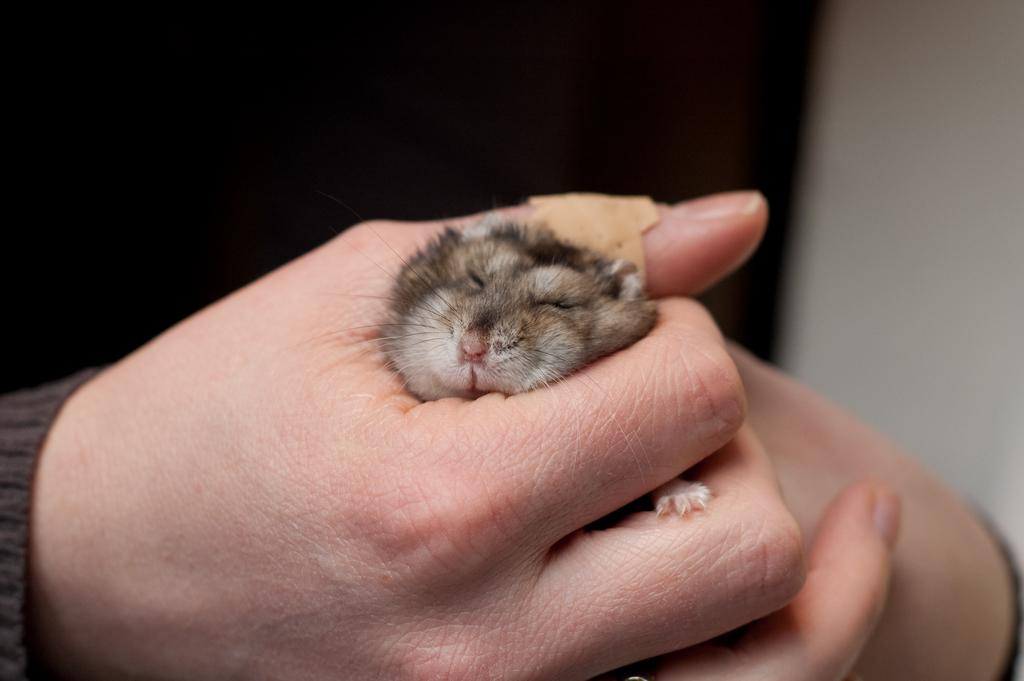What is being held by the hands in the image? The hands of a person are holding a rat in the image. Can you describe the background of the image? The background of the image is blurred. What is the purpose of the man standing in the field in the image? There is no man standing in a field in the image; it only features hands holding a rat with a blurred background. 